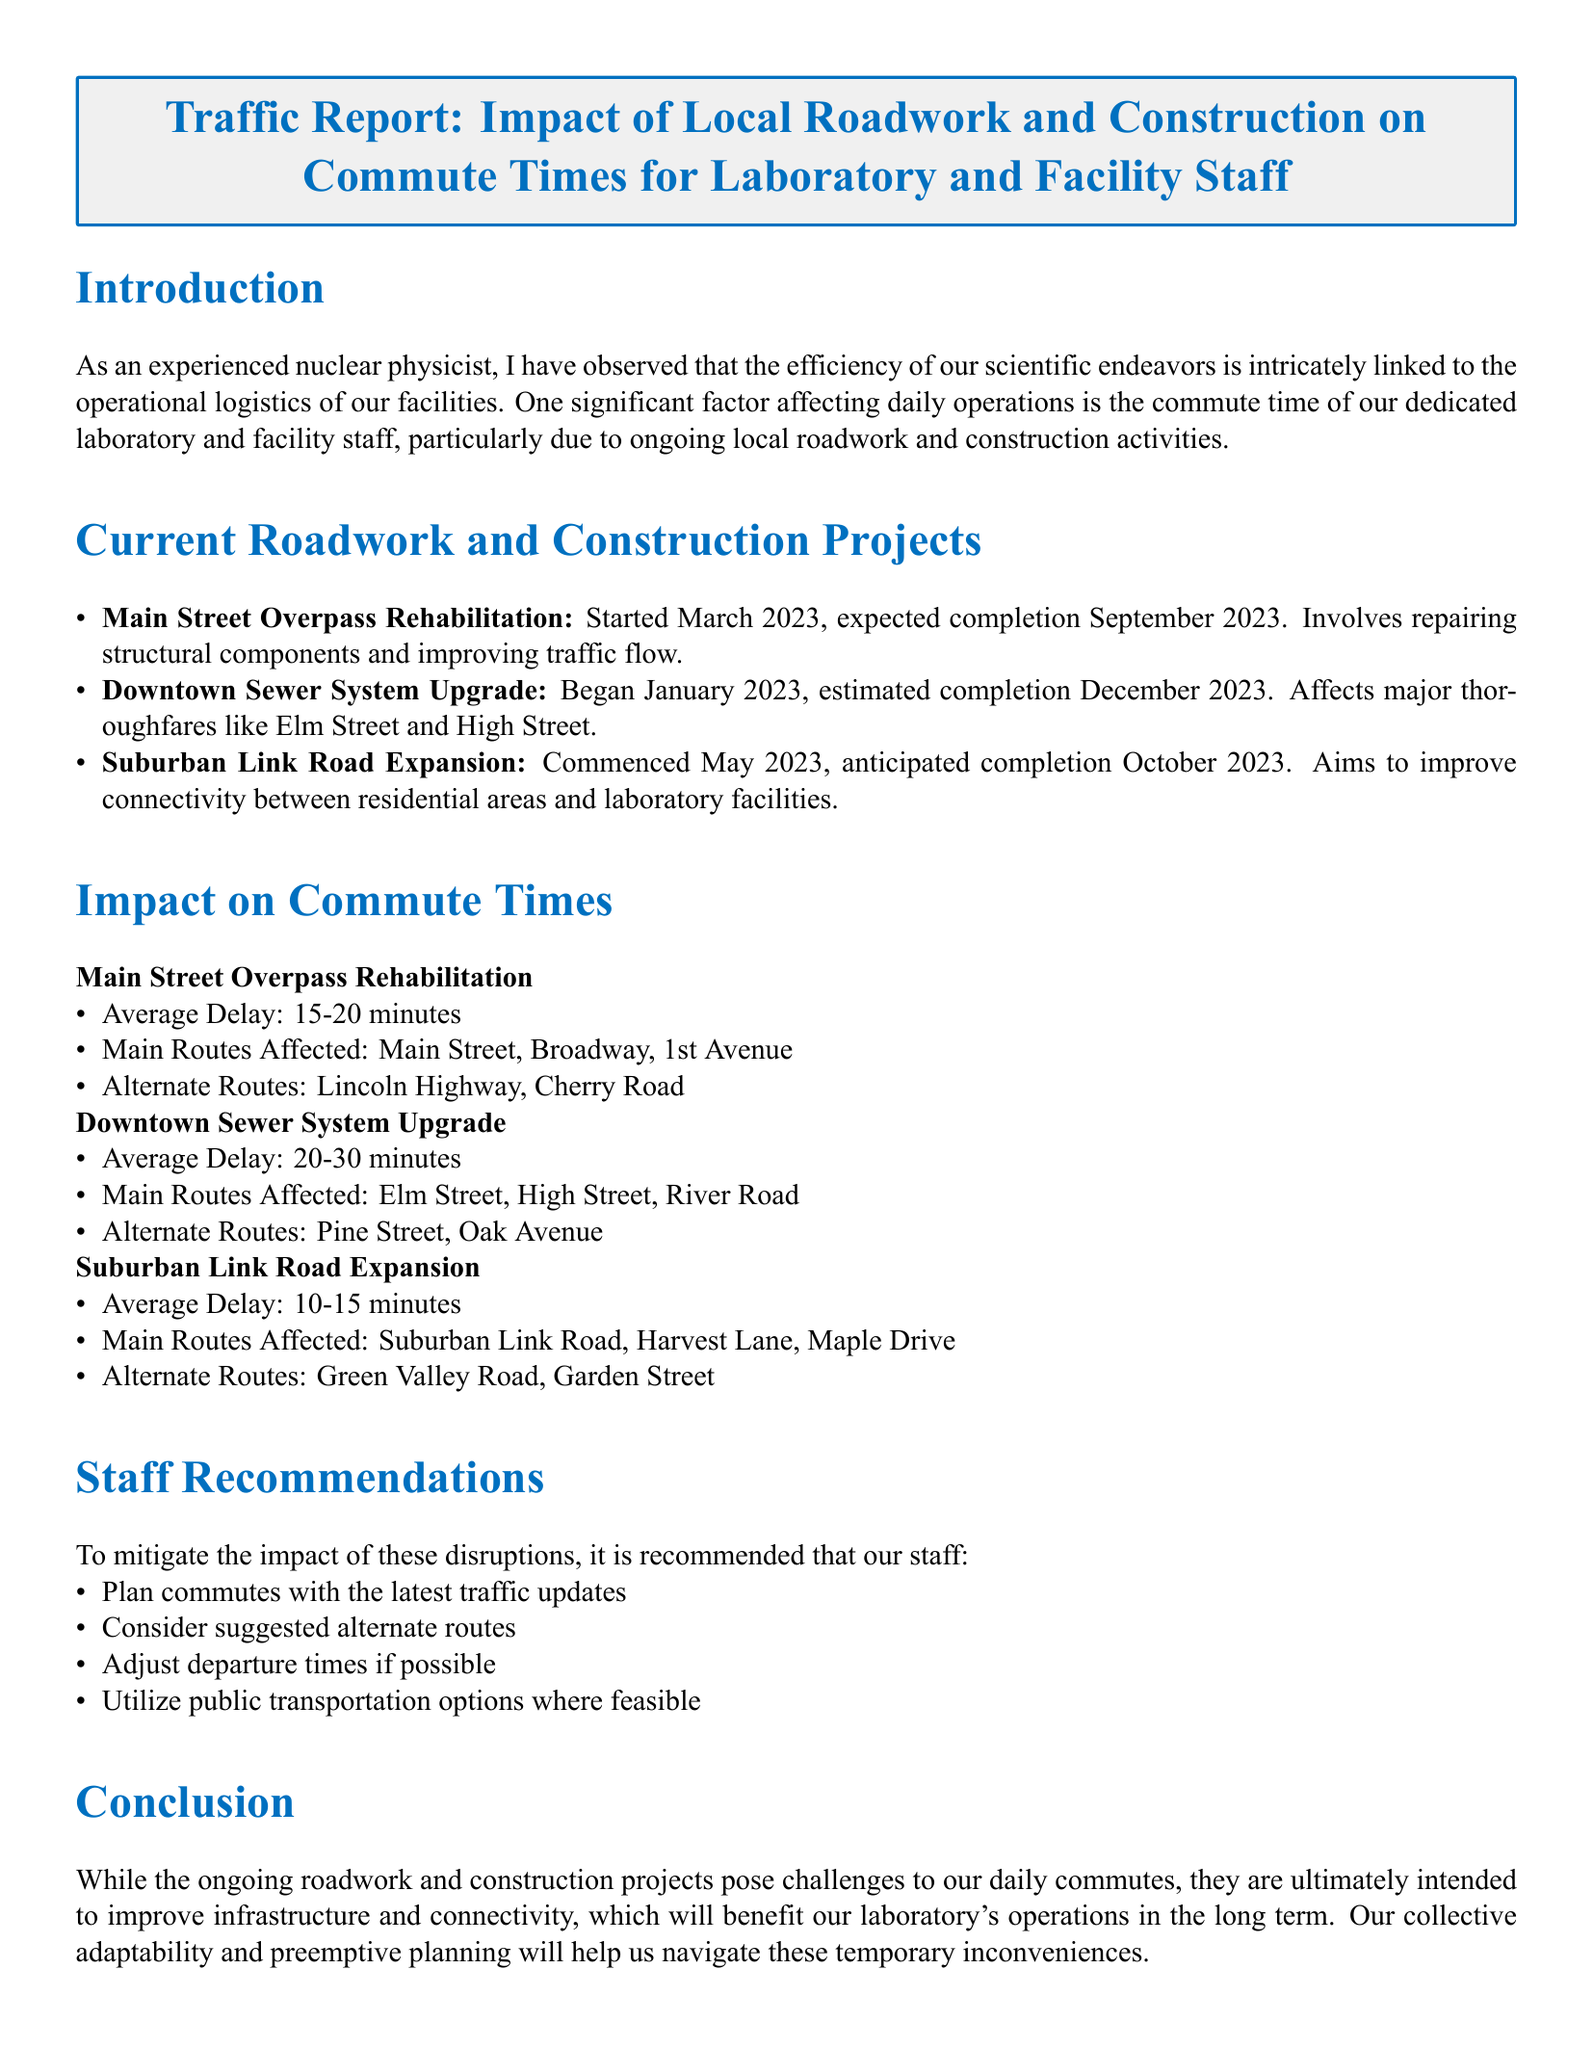What is the average delay caused by the Downtown Sewer System Upgrade? The average delay is mentioned under the impact section specifically for the project, which states it is 20-30 minutes.
Answer: 20-30 minutes When is the expected completion date for the Suburban Link Road Expansion? The document lists the anticipated completion date for this project, which is October 2023.
Answer: October 2023 What are the main routes affected by the Main Street Overpass Rehabilitation? The affected main routes are specified in the impact section for this project, listing Main Street, Broadway, and 1st Avenue.
Answer: Main Street, Broadway, 1st Avenue Which construction project began in January 2023? The document outlines the construction projects and specifies that the Downtown Sewer System Upgrade began in January 2023.
Answer: Downtown Sewer System Upgrade What is a recommended action to mitigate the impact of roadwork on commutes? The document provides staff recommendations, highlighting the importance of planning commutes with the latest traffic updates.
Answer: Plan commutes with the latest traffic updates What type of infrastructure is being improved by the ongoing roadwork? The introduction notes that the goal of these projects is to improve infrastructure and connectivity for laboratory operations.
Answer: Infrastructure and connectivity How long has the Main Street Overpass Rehabilitation project been ongoing as of now? The start date of this project is given as March 2023, and considering the current date mentioned is October 2023, it has been ongoing for approximately 7 months.
Answer: 7 months What is the primary aim of the Suburban Link Road Expansion? The document mentions the primary aim of this project as improving connectivity between residential areas and laboratory facilities.
Answer: Improve connectivity 